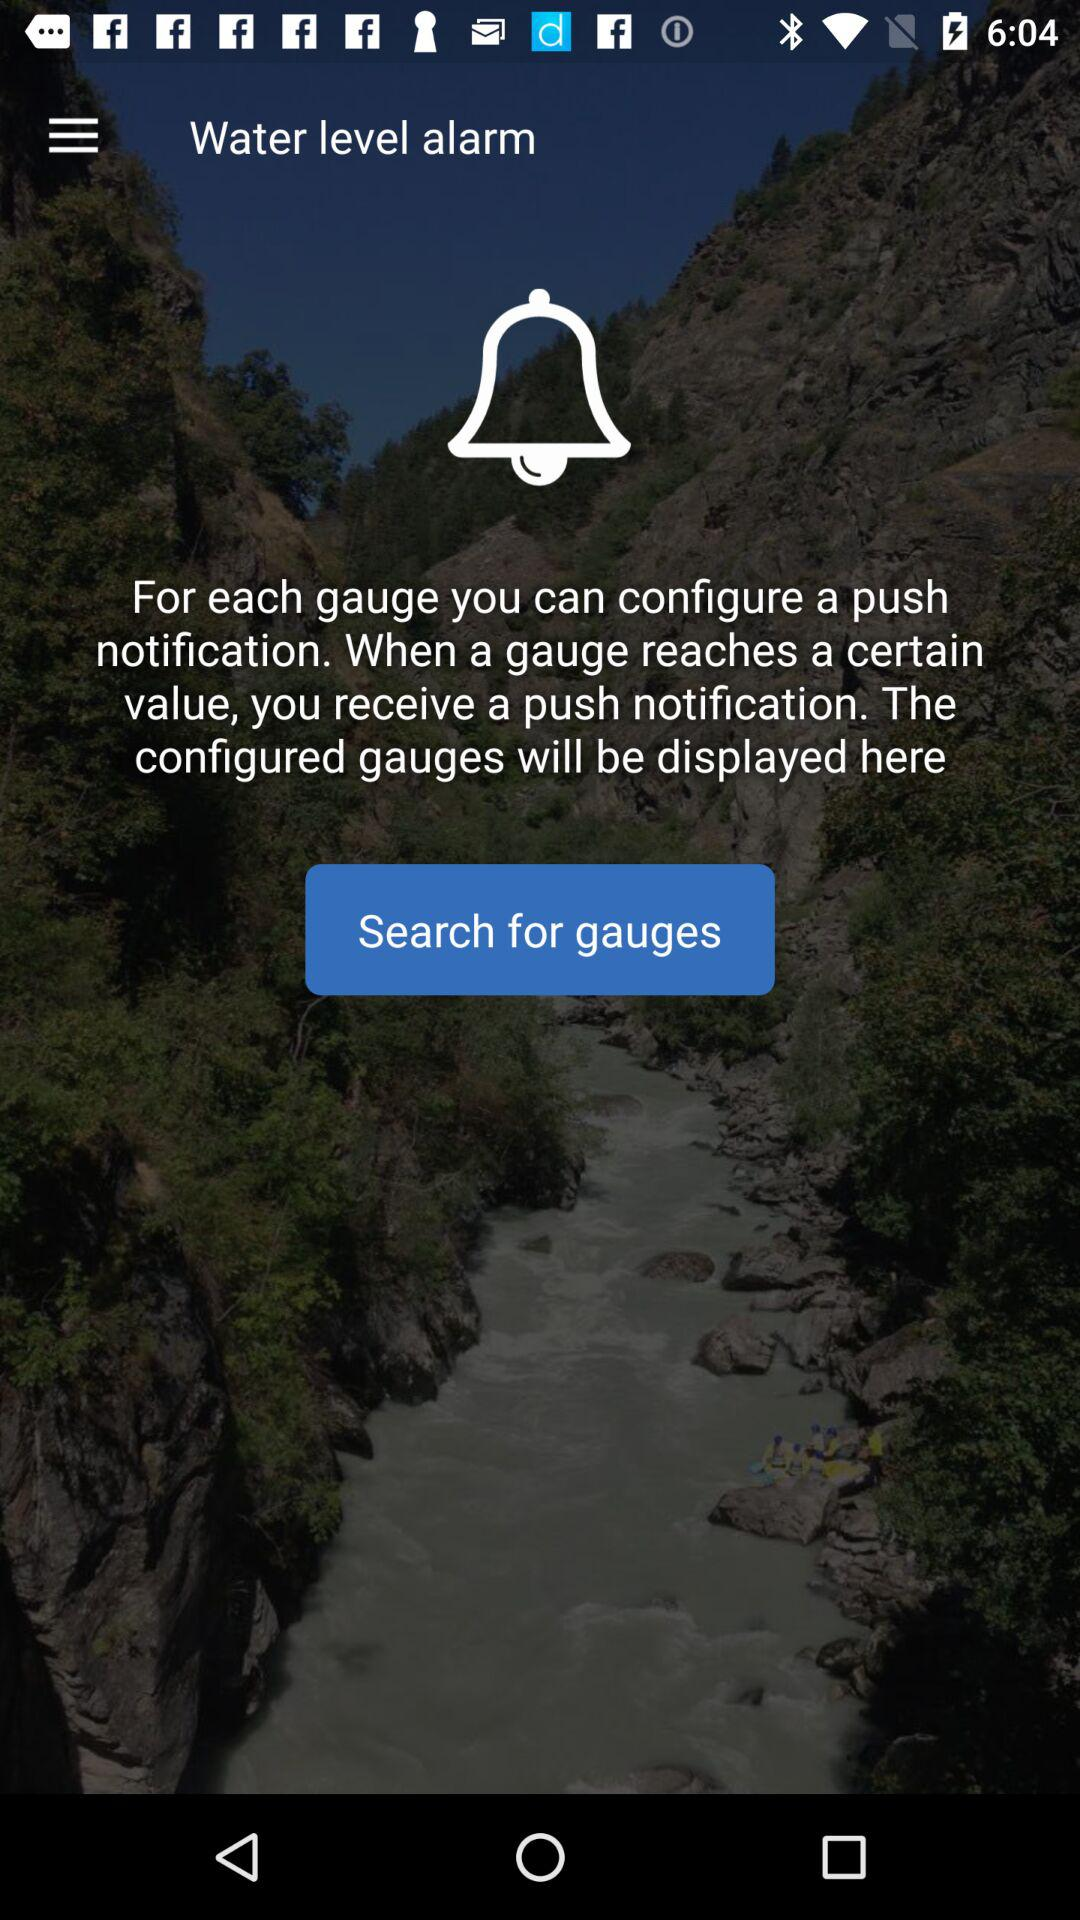What is a water level alarm?
When the provided information is insufficient, respond with <no answer>. <no answer> 